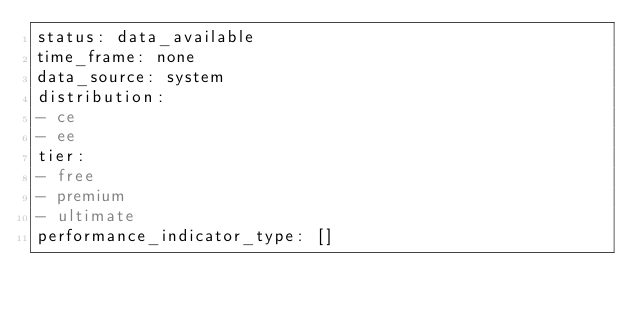Convert code to text. <code><loc_0><loc_0><loc_500><loc_500><_YAML_>status: data_available
time_frame: none
data_source: system
distribution:
- ce
- ee
tier:
- free
- premium
- ultimate
performance_indicator_type: []
</code> 